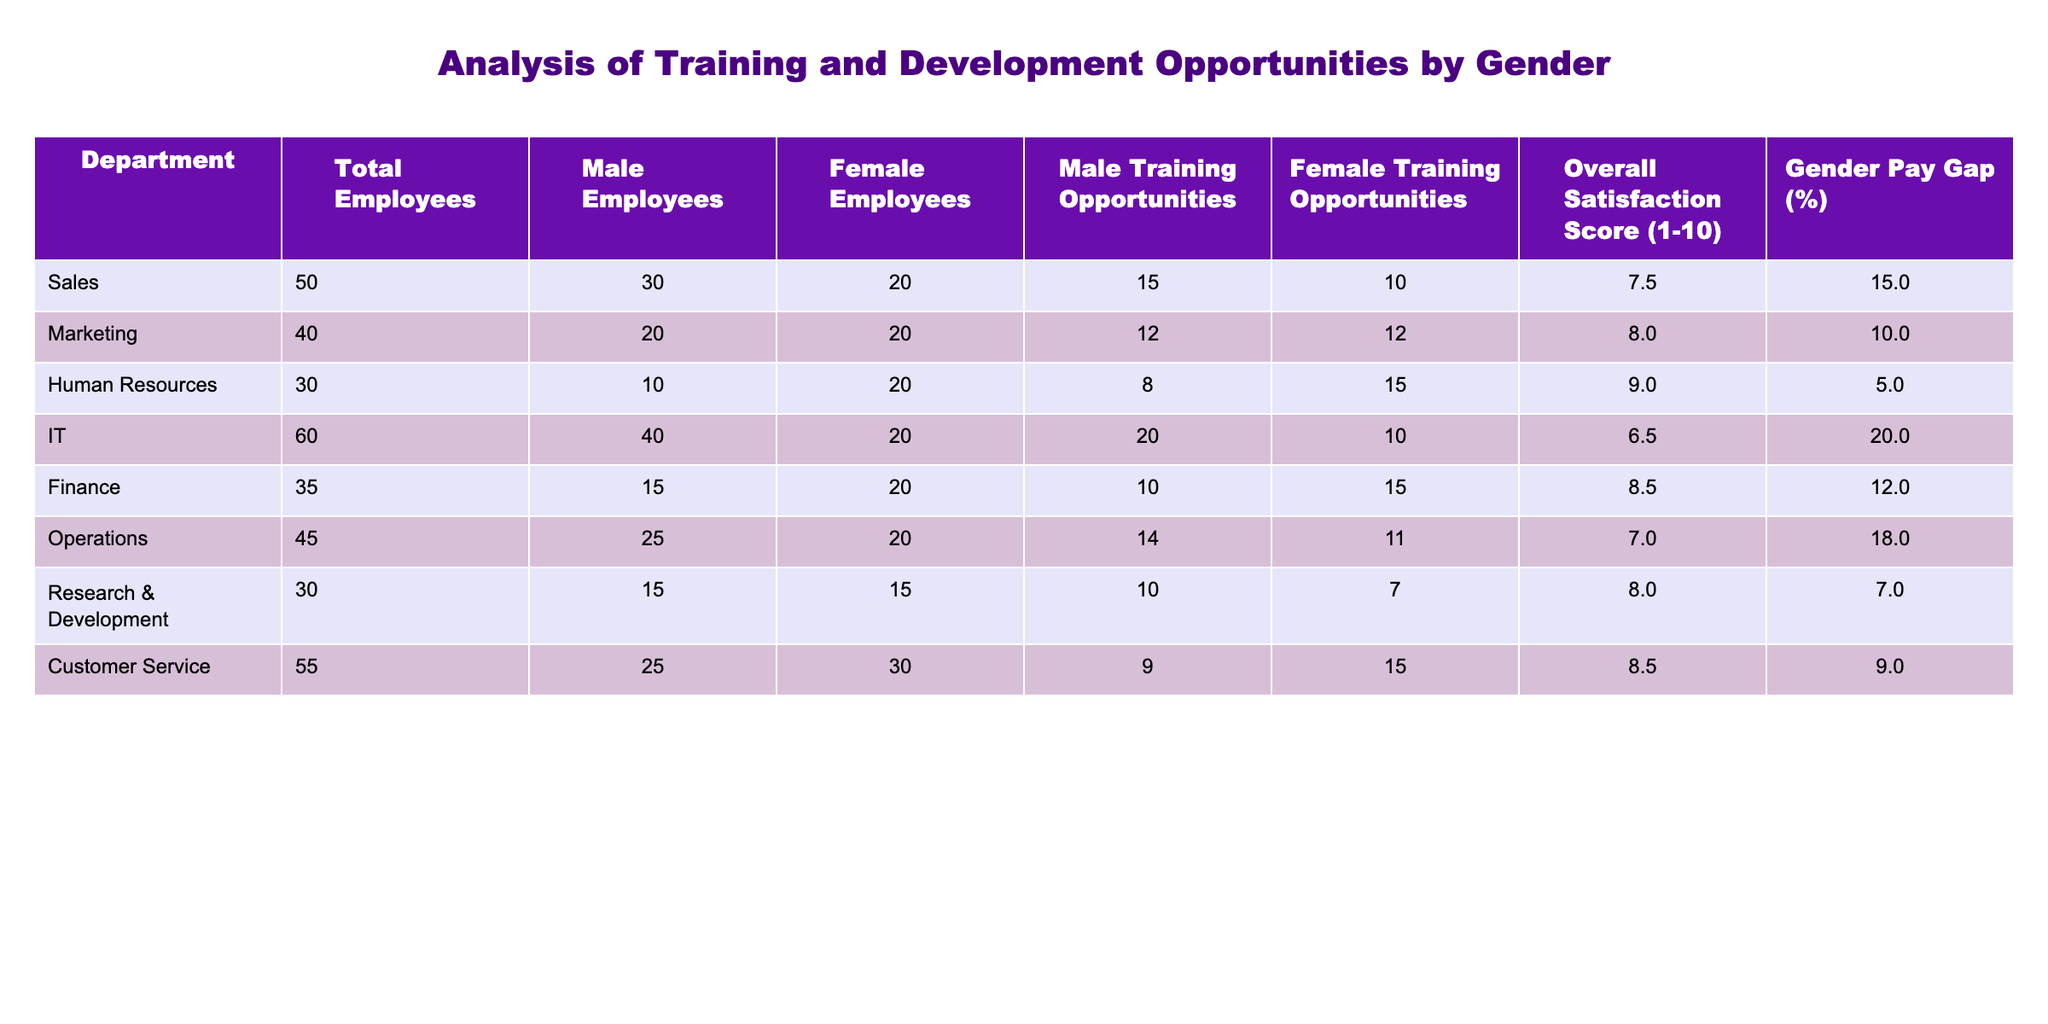What is the total number of female employees in the Sales department? In the table, under the Sales department, the column "Female Employees" shows the value 20.
Answer: 20 What is the overall satisfaction score for the Human Resources department? For the Human Resources row, the column "Overall Satisfaction Score (1-10)" lists the score as 9.0.
Answer: 9.0 Which department has the highest number of training opportunities for male employees? By looking at the "Male Training Opportunities" column, the IT department has the highest value of 20.
Answer: IT Is there a gender pay gap present in the Marketing department? The "Gender Pay Gap (%)" column shows a value of 10 for the Marketing department, indicating a gender pay gap does exist.
Answer: Yes What is the average number of training opportunities given to female employees across all departments? To find the average, sum the female training opportunities (10 + 12 + 15 + 10 + 15 + 11 + 7 + 15) = 95, and then divide by the number of departments (8): 95 / 8 = 11.875.
Answer: 11.875 Which department has the lowest overall satisfaction score? Assessing the "Overall Satisfaction Score (1-10)" column, the IT department has the lowest score of 6.5.
Answer: IT In which department do male employees receive more training opportunities than female employees? Comparing the "Male Training Opportunities" and "Female Training Opportunities" columns, this is true for the Sales, IT, and Operations departments.
Answer: Sales, IT, and Operations What is the difference in the number of male and female training opportunities in the Finance department? In the Finance row, the male training opportunities are 10 and female training opportunities are 15. The difference is 15 - 10 = 5.
Answer: 5 Does the Research & Development department have a gender pay gap greater than 5%? The gap percentage for Research & Development in the "Gender Pay Gap (%)" column is 7, which indicates that it does have a gender pay gap greater than 5%.
Answer: Yes 